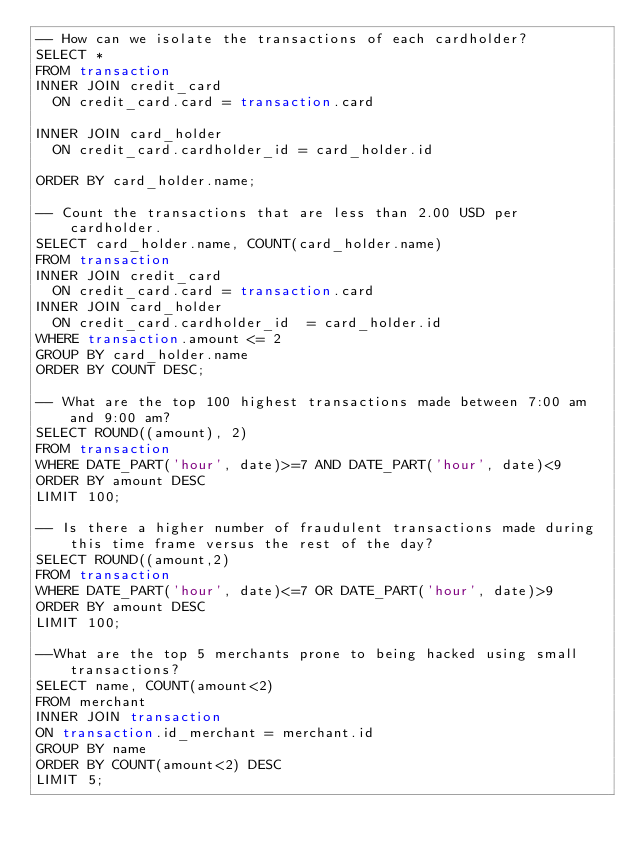Convert code to text. <code><loc_0><loc_0><loc_500><loc_500><_SQL_>-- How can we isolate the transactions of each cardholder?
SELECT *
FROM transaction
INNER JOIN credit_card
  ON credit_card.card = transaction.card

INNER JOIN card_holder
  ON credit_card.cardholder_id = card_holder.id

ORDER BY card_holder.name;

-- Count the transactions that are less than 2.00 USD per cardholder.
SELECT card_holder.name, COUNT(card_holder.name)
FROM transaction
INNER JOIN credit_card
  ON credit_card.card = transaction.card
INNER JOIN card_holder
  ON credit_card.cardholder_id  = card_holder.id
WHERE transaction.amount <= 2
GROUP BY card_holder.name
ORDER BY COUNT DESC;

-- What are the top 100 highest transactions made between 7:00 am and 9:00 am?
SELECT ROUND((amount), 2)
FROM transaction
WHERE DATE_PART('hour', date)>=7 AND DATE_PART('hour', date)<9
ORDER BY amount DESC
LIMIT 100;

-- Is there a higher number of fraudulent transactions made during this time frame versus the rest of the day?
SELECT ROUND((amount,2)
FROM transaction
WHERE DATE_PART('hour', date)<=7 OR DATE_PART('hour', date)>9
ORDER BY amount DESC
LIMIT 100;

--What are the top 5 merchants prone to being hacked using small transactions?
SELECT name, COUNT(amount<2)
FROM merchant
INNER JOIN transaction
ON transaction.id_merchant = merchant.id
GROUP BY name
ORDER BY COUNT(amount<2) DESC
LIMIT 5;</code> 